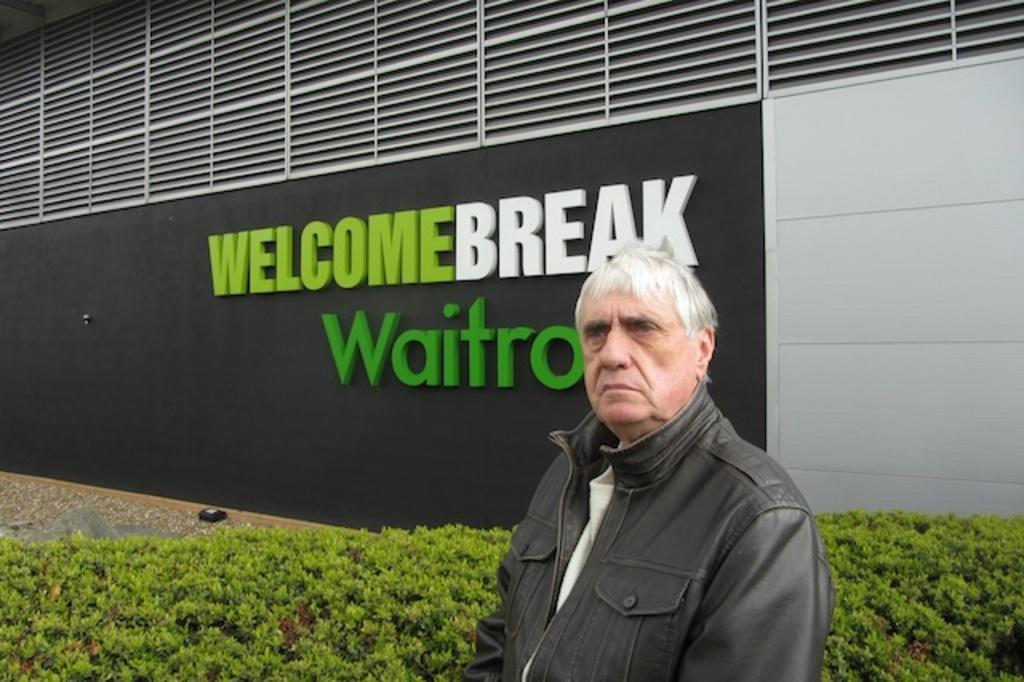Can you describe this image briefly? This image consists of a man wearing a black jacket. Behind him, there are small plants. In the background, we can see a building on which there is a black color and there is a text. 